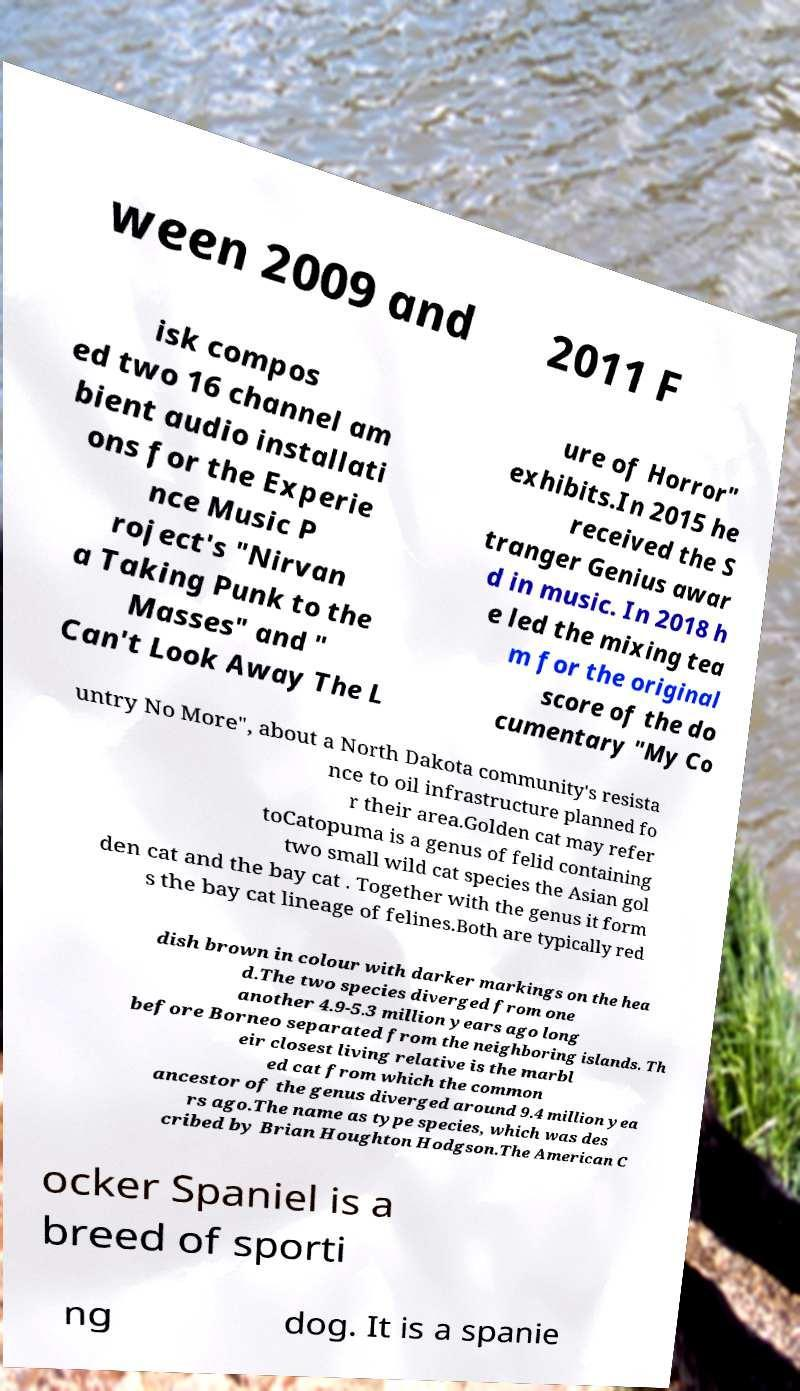Please identify and transcribe the text found in this image. ween 2009 and 2011 F isk compos ed two 16 channel am bient audio installati ons for the Experie nce Music P roject's "Nirvan a Taking Punk to the Masses" and " Can't Look Away The L ure of Horror" exhibits.In 2015 he received the S tranger Genius awar d in music. In 2018 h e led the mixing tea m for the original score of the do cumentary "My Co untry No More", about a North Dakota community's resista nce to oil infrastructure planned fo r their area.Golden cat may refer toCatopuma is a genus of felid containing two small wild cat species the Asian gol den cat and the bay cat . Together with the genus it form s the bay cat lineage of felines.Both are typically red dish brown in colour with darker markings on the hea d.The two species diverged from one another 4.9-5.3 million years ago long before Borneo separated from the neighboring islands. Th eir closest living relative is the marbl ed cat from which the common ancestor of the genus diverged around 9.4 million yea rs ago.The name as type species, which was des cribed by Brian Houghton Hodgson.The American C ocker Spaniel is a breed of sporti ng dog. It is a spanie 